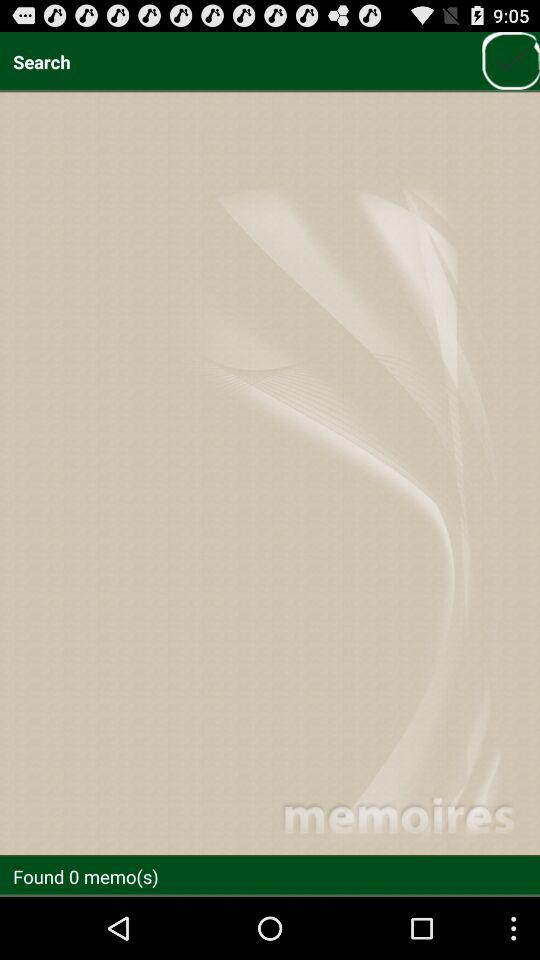Is there any memo? There is 0 memo. 